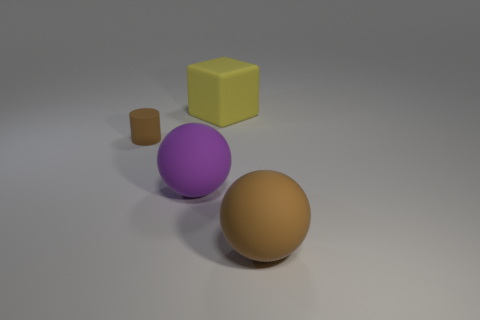Add 1 purple things. How many objects exist? 5 Subtract all cylinders. How many objects are left? 3 Subtract all big purple balls. Subtract all small rubber things. How many objects are left? 2 Add 4 big matte balls. How many big matte balls are left? 6 Add 1 tiny cyan metal things. How many tiny cyan metal things exist? 1 Subtract 1 purple spheres. How many objects are left? 3 